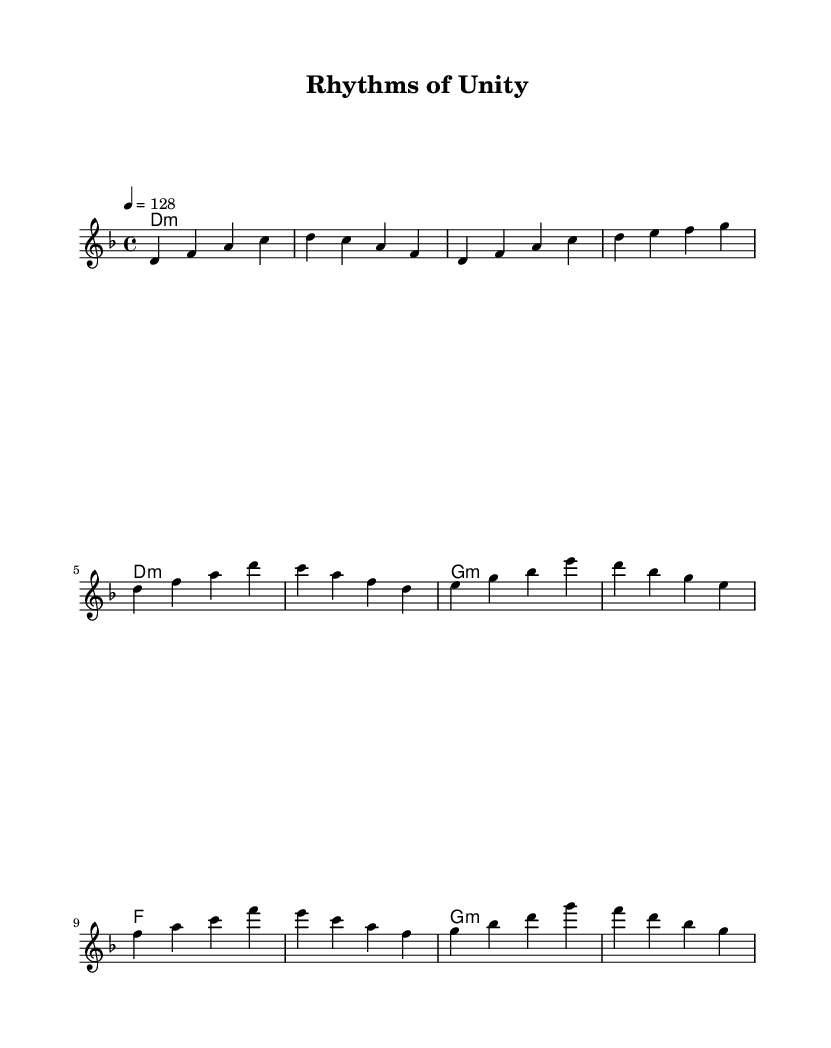What is the key signature of this music? The key signature is D minor, which contains one flat (B flat). This can be identified by looking at the key signature indicated at the beginning of the score.
Answer: D minor What is the time signature of this music? The time signature is 4/4, which means there are four beats in each measure and the quarter note gets one beat. This can be found at the beginning of the score right after the key signature.
Answer: 4/4 What is the tempo marking of the piece? The tempo is marked at 128 beats per minute, which indicates the speed of the music. This is noted at the beginning of the score following the time signature.
Answer: 128 How many measures are in the verse section of the music? The verse section contains four measures, which can be counted from the melody notation in that section. Each group of notes separated by vertical lines (bar lines) represents one measure.
Answer: 4 In which section does the note "g" appear? The note "g" appears in the chorus section of the music. This can be determined by examining the melody and noting which pitches are present in the chorus part, which is marked after the verse.
Answer: Chorus Which harmonic chord follows the first measure of the intro? The harmonic chord following the first measure of the intro is D minor. This is indicated by the chord symbols written above the melody in the score.
Answer: D minor What is the overall theme of this dance music? The overall theme is social justice, reflecting the title "Rhythms of Unity" and the context of fusion dance music. While this theme isn't directly found on the sheet music, it can be derived from the title and context provided.
Answer: Social justice 